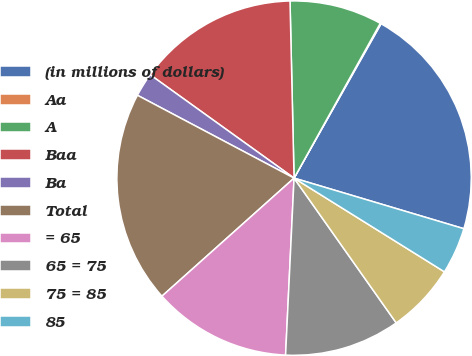<chart> <loc_0><loc_0><loc_500><loc_500><pie_chart><fcel>(in millions of dollars)<fcel>Aa<fcel>A<fcel>Baa<fcel>Ba<fcel>Total<fcel>= 65<fcel>65 = 75<fcel>75 = 85<fcel>85<nl><fcel>21.44%<fcel>0.08%<fcel>8.45%<fcel>14.72%<fcel>2.17%<fcel>19.35%<fcel>12.63%<fcel>10.54%<fcel>6.35%<fcel>4.26%<nl></chart> 